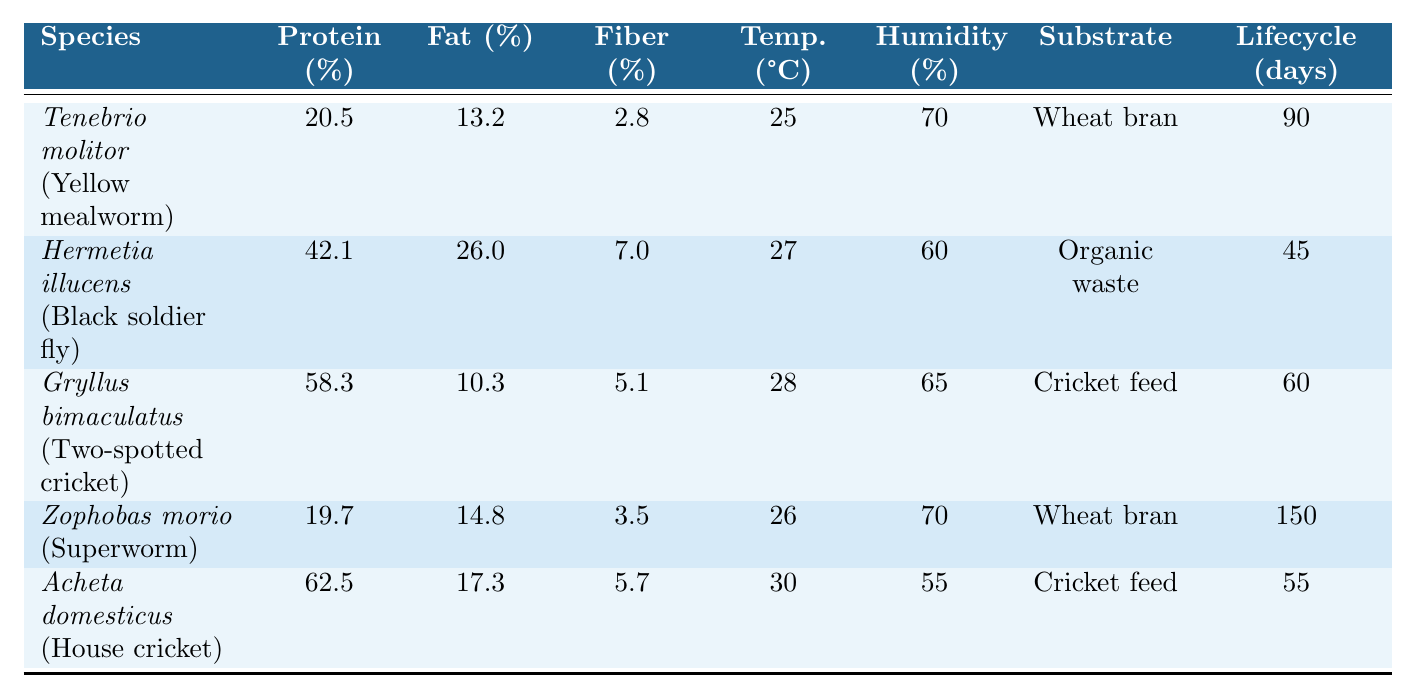What is the protein content of Acheta domesticus? The protein content for Acheta domesticus, which is also known as the House cricket, is listed directly in the table. It shows a protein content of 62.5%.
Answer: 62.5% Which insect feed species has the highest fat content? By examining the fat content values in the table, Hermetia illucens (Black soldier fly) has the highest fat content at 26.0%.
Answer: Hermetia illucens What is the average fiber content of all the insect species listed? To find the average, sum the fiber contents: (2.8 + 7.0 + 5.1 + 3.5 + 5.7) = 24.1. There are 5 species, so the average is 24.1 / 5 = 4.82.
Answer: 4.82 Is Zophobas morio more humid tolerant than Gryllus bimaculatus? The optimal humidity for Zophobas morio is 70%, while for Gryllus bimaculatus it is 65%. Since 70% is greater than 65%, Zophobas morio is indeed more humid tolerant.
Answer: Yes What is the total lifecycle duration of Tenebrio molitor and Acheta domesticus combined? The lifecycle duration for Tenebrio molitor is 90 days and for Acheta domesticus is 55 days. Adding these gives 90 + 55 = 145 days.
Answer: 145 days Among the listed species, which one has the lowest protein content? By comparing the protein contents in the table, Zophobas morio has the lowest protein content at 19.7%.
Answer: Zophobas morio Does Gryllus bimaculatus have a shorter lifecycle than Hermetia illucens? The lifecycle duration for Gryllus bimaculatus is 60 days, while it is 45 days for Hermetia illucens. Since 60 days is longer than 45 days, Gryllus bimaculatus does not have a shorter lifecycle.
Answer: No What is the temperature range for all five insect species when keeping them for rearing? The optimal temperatures listed are 25, 27, 28, 26, and 30 degrees Celsius. The minimum is 25 and the maximum is 30, leading to a range of 25 to 30 degrees Celsius.
Answer: 25 to 30 degrees Celsius How much higher is the protein content of Gryllus bimaculatus compared to Zophobas morio? The protein content of Gryllus bimaculatus is 58.3% while that of Zophobas morio is 19.7%. The difference is calculated as 58.3 - 19.7 = 38.6%.
Answer: 38.6% What is the substrate used for most insect species in the table? Reviewing the substrates listed, both Tenebrio molitor and Zophobas morio use "Wheat bran", while others use "Organic waste" or "Cricket feed". Wheat bran is used by two species, making it the most common substrate.
Answer: Wheat bran 